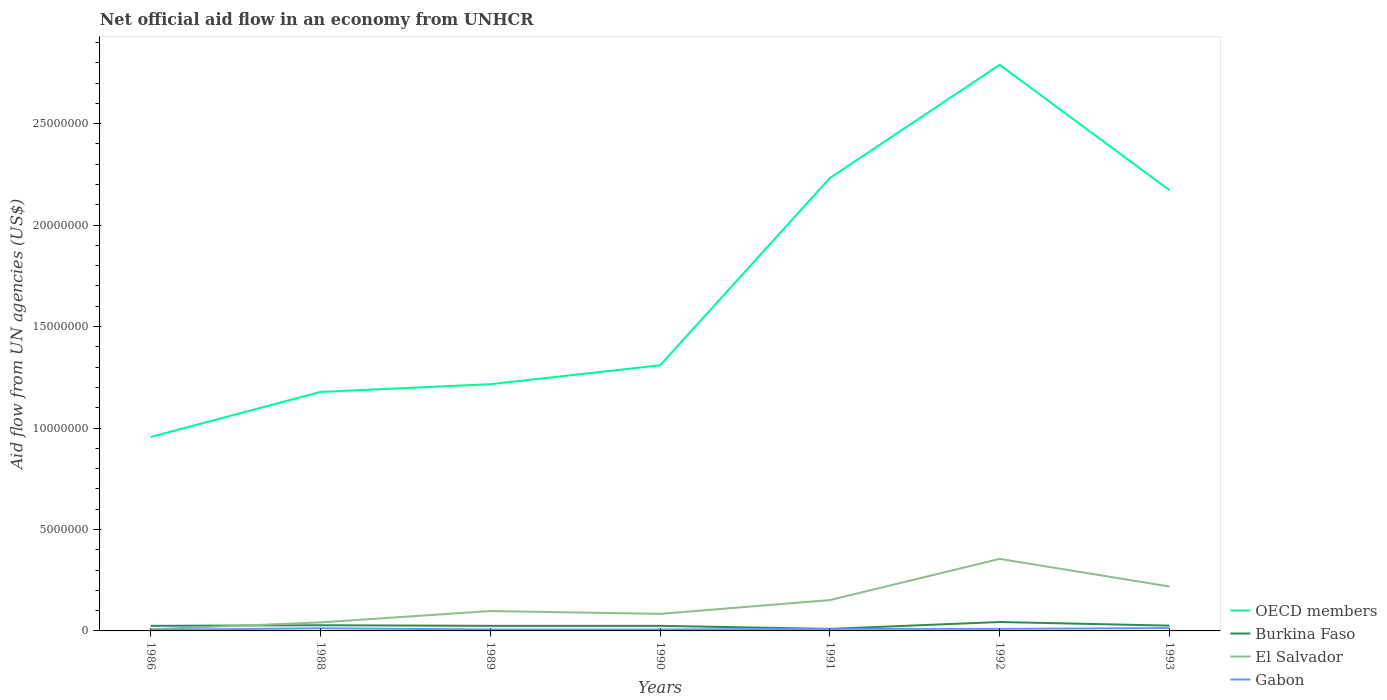Does the line corresponding to Gabon intersect with the line corresponding to El Salvador?
Offer a terse response. No. Is the number of lines equal to the number of legend labels?
Your response must be concise. Yes. Across all years, what is the maximum net official aid flow in Burkina Faso?
Give a very brief answer. 1.00e+05. In which year was the net official aid flow in El Salvador maximum?
Give a very brief answer. 1986. What is the total net official aid flow in OECD members in the graph?
Your answer should be compact. -1.83e+07. What is the difference between the highest and the second highest net official aid flow in OECD members?
Make the answer very short. 1.83e+07. How many years are there in the graph?
Provide a short and direct response. 7. Does the graph contain any zero values?
Offer a terse response. No. Where does the legend appear in the graph?
Offer a very short reply. Bottom right. How many legend labels are there?
Offer a terse response. 4. How are the legend labels stacked?
Give a very brief answer. Vertical. What is the title of the graph?
Provide a succinct answer. Net official aid flow in an economy from UNHCR. What is the label or title of the Y-axis?
Provide a succinct answer. Aid flow from UN agencies (US$). What is the Aid flow from UN agencies (US$) in OECD members in 1986?
Offer a very short reply. 9.56e+06. What is the Aid flow from UN agencies (US$) of El Salvador in 1986?
Your response must be concise. 8.00e+04. What is the Aid flow from UN agencies (US$) in OECD members in 1988?
Offer a terse response. 1.18e+07. What is the Aid flow from UN agencies (US$) of Burkina Faso in 1988?
Ensure brevity in your answer.  2.80e+05. What is the Aid flow from UN agencies (US$) in Gabon in 1988?
Your response must be concise. 1.30e+05. What is the Aid flow from UN agencies (US$) of OECD members in 1989?
Give a very brief answer. 1.22e+07. What is the Aid flow from UN agencies (US$) of El Salvador in 1989?
Offer a very short reply. 9.80e+05. What is the Aid flow from UN agencies (US$) of OECD members in 1990?
Your response must be concise. 1.31e+07. What is the Aid flow from UN agencies (US$) in El Salvador in 1990?
Provide a short and direct response. 8.40e+05. What is the Aid flow from UN agencies (US$) in OECD members in 1991?
Offer a very short reply. 2.23e+07. What is the Aid flow from UN agencies (US$) in El Salvador in 1991?
Give a very brief answer. 1.52e+06. What is the Aid flow from UN agencies (US$) of OECD members in 1992?
Give a very brief answer. 2.79e+07. What is the Aid flow from UN agencies (US$) of Burkina Faso in 1992?
Keep it short and to the point. 4.40e+05. What is the Aid flow from UN agencies (US$) of El Salvador in 1992?
Give a very brief answer. 3.55e+06. What is the Aid flow from UN agencies (US$) in OECD members in 1993?
Offer a terse response. 2.17e+07. What is the Aid flow from UN agencies (US$) of El Salvador in 1993?
Ensure brevity in your answer.  2.19e+06. Across all years, what is the maximum Aid flow from UN agencies (US$) of OECD members?
Your answer should be very brief. 2.79e+07. Across all years, what is the maximum Aid flow from UN agencies (US$) of Burkina Faso?
Your answer should be compact. 4.40e+05. Across all years, what is the maximum Aid flow from UN agencies (US$) of El Salvador?
Make the answer very short. 3.55e+06. Across all years, what is the maximum Aid flow from UN agencies (US$) in Gabon?
Your response must be concise. 1.40e+05. Across all years, what is the minimum Aid flow from UN agencies (US$) of OECD members?
Keep it short and to the point. 9.56e+06. Across all years, what is the minimum Aid flow from UN agencies (US$) in El Salvador?
Your response must be concise. 8.00e+04. Across all years, what is the minimum Aid flow from UN agencies (US$) of Gabon?
Give a very brief answer. 5.00e+04. What is the total Aid flow from UN agencies (US$) in OECD members in the graph?
Your response must be concise. 1.19e+08. What is the total Aid flow from UN agencies (US$) in Burkina Faso in the graph?
Provide a succinct answer. 1.83e+06. What is the total Aid flow from UN agencies (US$) of El Salvador in the graph?
Provide a succinct answer. 9.58e+06. What is the difference between the Aid flow from UN agencies (US$) of OECD members in 1986 and that in 1988?
Give a very brief answer. -2.22e+06. What is the difference between the Aid flow from UN agencies (US$) in El Salvador in 1986 and that in 1988?
Offer a terse response. -3.40e+05. What is the difference between the Aid flow from UN agencies (US$) of Gabon in 1986 and that in 1988?
Give a very brief answer. -8.00e+04. What is the difference between the Aid flow from UN agencies (US$) in OECD members in 1986 and that in 1989?
Give a very brief answer. -2.60e+06. What is the difference between the Aid flow from UN agencies (US$) of Burkina Faso in 1986 and that in 1989?
Your answer should be compact. 0. What is the difference between the Aid flow from UN agencies (US$) of El Salvador in 1986 and that in 1989?
Your answer should be compact. -9.00e+05. What is the difference between the Aid flow from UN agencies (US$) in OECD members in 1986 and that in 1990?
Make the answer very short. -3.53e+06. What is the difference between the Aid flow from UN agencies (US$) in Burkina Faso in 1986 and that in 1990?
Make the answer very short. 0. What is the difference between the Aid flow from UN agencies (US$) of El Salvador in 1986 and that in 1990?
Give a very brief answer. -7.60e+05. What is the difference between the Aid flow from UN agencies (US$) of Gabon in 1986 and that in 1990?
Make the answer very short. -2.00e+04. What is the difference between the Aid flow from UN agencies (US$) of OECD members in 1986 and that in 1991?
Keep it short and to the point. -1.28e+07. What is the difference between the Aid flow from UN agencies (US$) in El Salvador in 1986 and that in 1991?
Keep it short and to the point. -1.44e+06. What is the difference between the Aid flow from UN agencies (US$) in Gabon in 1986 and that in 1991?
Make the answer very short. -5.00e+04. What is the difference between the Aid flow from UN agencies (US$) in OECD members in 1986 and that in 1992?
Your answer should be compact. -1.83e+07. What is the difference between the Aid flow from UN agencies (US$) in El Salvador in 1986 and that in 1992?
Offer a terse response. -3.47e+06. What is the difference between the Aid flow from UN agencies (US$) of OECD members in 1986 and that in 1993?
Provide a short and direct response. -1.22e+07. What is the difference between the Aid flow from UN agencies (US$) of El Salvador in 1986 and that in 1993?
Provide a succinct answer. -2.11e+06. What is the difference between the Aid flow from UN agencies (US$) in Gabon in 1986 and that in 1993?
Offer a terse response. -9.00e+04. What is the difference between the Aid flow from UN agencies (US$) of OECD members in 1988 and that in 1989?
Offer a very short reply. -3.80e+05. What is the difference between the Aid flow from UN agencies (US$) of Burkina Faso in 1988 and that in 1989?
Make the answer very short. 3.00e+04. What is the difference between the Aid flow from UN agencies (US$) of El Salvador in 1988 and that in 1989?
Ensure brevity in your answer.  -5.60e+05. What is the difference between the Aid flow from UN agencies (US$) in Gabon in 1988 and that in 1989?
Provide a short and direct response. 6.00e+04. What is the difference between the Aid flow from UN agencies (US$) in OECD members in 1988 and that in 1990?
Make the answer very short. -1.31e+06. What is the difference between the Aid flow from UN agencies (US$) of Burkina Faso in 1988 and that in 1990?
Ensure brevity in your answer.  3.00e+04. What is the difference between the Aid flow from UN agencies (US$) of El Salvador in 1988 and that in 1990?
Give a very brief answer. -4.20e+05. What is the difference between the Aid flow from UN agencies (US$) in Gabon in 1988 and that in 1990?
Give a very brief answer. 6.00e+04. What is the difference between the Aid flow from UN agencies (US$) in OECD members in 1988 and that in 1991?
Give a very brief answer. -1.05e+07. What is the difference between the Aid flow from UN agencies (US$) in El Salvador in 1988 and that in 1991?
Ensure brevity in your answer.  -1.10e+06. What is the difference between the Aid flow from UN agencies (US$) in OECD members in 1988 and that in 1992?
Keep it short and to the point. -1.61e+07. What is the difference between the Aid flow from UN agencies (US$) in Burkina Faso in 1988 and that in 1992?
Your answer should be very brief. -1.60e+05. What is the difference between the Aid flow from UN agencies (US$) in El Salvador in 1988 and that in 1992?
Offer a terse response. -3.13e+06. What is the difference between the Aid flow from UN agencies (US$) of OECD members in 1988 and that in 1993?
Offer a terse response. -9.94e+06. What is the difference between the Aid flow from UN agencies (US$) of Burkina Faso in 1988 and that in 1993?
Ensure brevity in your answer.  2.00e+04. What is the difference between the Aid flow from UN agencies (US$) of El Salvador in 1988 and that in 1993?
Your answer should be very brief. -1.77e+06. What is the difference between the Aid flow from UN agencies (US$) of Gabon in 1988 and that in 1993?
Offer a terse response. -10000. What is the difference between the Aid flow from UN agencies (US$) of OECD members in 1989 and that in 1990?
Make the answer very short. -9.30e+05. What is the difference between the Aid flow from UN agencies (US$) in Gabon in 1989 and that in 1990?
Make the answer very short. 0. What is the difference between the Aid flow from UN agencies (US$) of OECD members in 1989 and that in 1991?
Your response must be concise. -1.02e+07. What is the difference between the Aid flow from UN agencies (US$) in Burkina Faso in 1989 and that in 1991?
Give a very brief answer. 1.50e+05. What is the difference between the Aid flow from UN agencies (US$) of El Salvador in 1989 and that in 1991?
Provide a succinct answer. -5.40e+05. What is the difference between the Aid flow from UN agencies (US$) in Gabon in 1989 and that in 1991?
Offer a very short reply. -3.00e+04. What is the difference between the Aid flow from UN agencies (US$) in OECD members in 1989 and that in 1992?
Give a very brief answer. -1.57e+07. What is the difference between the Aid flow from UN agencies (US$) of Burkina Faso in 1989 and that in 1992?
Your answer should be compact. -1.90e+05. What is the difference between the Aid flow from UN agencies (US$) of El Salvador in 1989 and that in 1992?
Give a very brief answer. -2.57e+06. What is the difference between the Aid flow from UN agencies (US$) of Gabon in 1989 and that in 1992?
Make the answer very short. -3.00e+04. What is the difference between the Aid flow from UN agencies (US$) of OECD members in 1989 and that in 1993?
Give a very brief answer. -9.56e+06. What is the difference between the Aid flow from UN agencies (US$) in Burkina Faso in 1989 and that in 1993?
Make the answer very short. -10000. What is the difference between the Aid flow from UN agencies (US$) of El Salvador in 1989 and that in 1993?
Make the answer very short. -1.21e+06. What is the difference between the Aid flow from UN agencies (US$) in OECD members in 1990 and that in 1991?
Your answer should be very brief. -9.23e+06. What is the difference between the Aid flow from UN agencies (US$) of El Salvador in 1990 and that in 1991?
Provide a succinct answer. -6.80e+05. What is the difference between the Aid flow from UN agencies (US$) in Gabon in 1990 and that in 1991?
Provide a succinct answer. -3.00e+04. What is the difference between the Aid flow from UN agencies (US$) of OECD members in 1990 and that in 1992?
Provide a short and direct response. -1.48e+07. What is the difference between the Aid flow from UN agencies (US$) in El Salvador in 1990 and that in 1992?
Your response must be concise. -2.71e+06. What is the difference between the Aid flow from UN agencies (US$) of Gabon in 1990 and that in 1992?
Ensure brevity in your answer.  -3.00e+04. What is the difference between the Aid flow from UN agencies (US$) of OECD members in 1990 and that in 1993?
Provide a short and direct response. -8.63e+06. What is the difference between the Aid flow from UN agencies (US$) in El Salvador in 1990 and that in 1993?
Ensure brevity in your answer.  -1.35e+06. What is the difference between the Aid flow from UN agencies (US$) of Gabon in 1990 and that in 1993?
Offer a terse response. -7.00e+04. What is the difference between the Aid flow from UN agencies (US$) of OECD members in 1991 and that in 1992?
Your response must be concise. -5.58e+06. What is the difference between the Aid flow from UN agencies (US$) in El Salvador in 1991 and that in 1992?
Your answer should be compact. -2.03e+06. What is the difference between the Aid flow from UN agencies (US$) of Gabon in 1991 and that in 1992?
Provide a short and direct response. 0. What is the difference between the Aid flow from UN agencies (US$) of OECD members in 1991 and that in 1993?
Offer a terse response. 6.00e+05. What is the difference between the Aid flow from UN agencies (US$) in Burkina Faso in 1991 and that in 1993?
Keep it short and to the point. -1.60e+05. What is the difference between the Aid flow from UN agencies (US$) in El Salvador in 1991 and that in 1993?
Offer a terse response. -6.70e+05. What is the difference between the Aid flow from UN agencies (US$) in Gabon in 1991 and that in 1993?
Provide a succinct answer. -4.00e+04. What is the difference between the Aid flow from UN agencies (US$) of OECD members in 1992 and that in 1993?
Your response must be concise. 6.18e+06. What is the difference between the Aid flow from UN agencies (US$) in El Salvador in 1992 and that in 1993?
Make the answer very short. 1.36e+06. What is the difference between the Aid flow from UN agencies (US$) of Gabon in 1992 and that in 1993?
Provide a succinct answer. -4.00e+04. What is the difference between the Aid flow from UN agencies (US$) of OECD members in 1986 and the Aid flow from UN agencies (US$) of Burkina Faso in 1988?
Your answer should be compact. 9.28e+06. What is the difference between the Aid flow from UN agencies (US$) in OECD members in 1986 and the Aid flow from UN agencies (US$) in El Salvador in 1988?
Provide a succinct answer. 9.14e+06. What is the difference between the Aid flow from UN agencies (US$) in OECD members in 1986 and the Aid flow from UN agencies (US$) in Gabon in 1988?
Offer a terse response. 9.43e+06. What is the difference between the Aid flow from UN agencies (US$) of Burkina Faso in 1986 and the Aid flow from UN agencies (US$) of El Salvador in 1988?
Keep it short and to the point. -1.70e+05. What is the difference between the Aid flow from UN agencies (US$) of El Salvador in 1986 and the Aid flow from UN agencies (US$) of Gabon in 1988?
Your response must be concise. -5.00e+04. What is the difference between the Aid flow from UN agencies (US$) of OECD members in 1986 and the Aid flow from UN agencies (US$) of Burkina Faso in 1989?
Give a very brief answer. 9.31e+06. What is the difference between the Aid flow from UN agencies (US$) of OECD members in 1986 and the Aid flow from UN agencies (US$) of El Salvador in 1989?
Offer a terse response. 8.58e+06. What is the difference between the Aid flow from UN agencies (US$) in OECD members in 1986 and the Aid flow from UN agencies (US$) in Gabon in 1989?
Offer a very short reply. 9.49e+06. What is the difference between the Aid flow from UN agencies (US$) of Burkina Faso in 1986 and the Aid flow from UN agencies (US$) of El Salvador in 1989?
Offer a very short reply. -7.30e+05. What is the difference between the Aid flow from UN agencies (US$) in OECD members in 1986 and the Aid flow from UN agencies (US$) in Burkina Faso in 1990?
Ensure brevity in your answer.  9.31e+06. What is the difference between the Aid flow from UN agencies (US$) in OECD members in 1986 and the Aid flow from UN agencies (US$) in El Salvador in 1990?
Offer a terse response. 8.72e+06. What is the difference between the Aid flow from UN agencies (US$) of OECD members in 1986 and the Aid flow from UN agencies (US$) of Gabon in 1990?
Offer a very short reply. 9.49e+06. What is the difference between the Aid flow from UN agencies (US$) of Burkina Faso in 1986 and the Aid flow from UN agencies (US$) of El Salvador in 1990?
Your answer should be very brief. -5.90e+05. What is the difference between the Aid flow from UN agencies (US$) of Burkina Faso in 1986 and the Aid flow from UN agencies (US$) of Gabon in 1990?
Your response must be concise. 1.80e+05. What is the difference between the Aid flow from UN agencies (US$) of El Salvador in 1986 and the Aid flow from UN agencies (US$) of Gabon in 1990?
Your response must be concise. 10000. What is the difference between the Aid flow from UN agencies (US$) in OECD members in 1986 and the Aid flow from UN agencies (US$) in Burkina Faso in 1991?
Provide a short and direct response. 9.46e+06. What is the difference between the Aid flow from UN agencies (US$) of OECD members in 1986 and the Aid flow from UN agencies (US$) of El Salvador in 1991?
Your answer should be compact. 8.04e+06. What is the difference between the Aid flow from UN agencies (US$) of OECD members in 1986 and the Aid flow from UN agencies (US$) of Gabon in 1991?
Give a very brief answer. 9.46e+06. What is the difference between the Aid flow from UN agencies (US$) in Burkina Faso in 1986 and the Aid flow from UN agencies (US$) in El Salvador in 1991?
Offer a terse response. -1.27e+06. What is the difference between the Aid flow from UN agencies (US$) of Burkina Faso in 1986 and the Aid flow from UN agencies (US$) of Gabon in 1991?
Ensure brevity in your answer.  1.50e+05. What is the difference between the Aid flow from UN agencies (US$) in El Salvador in 1986 and the Aid flow from UN agencies (US$) in Gabon in 1991?
Provide a short and direct response. -2.00e+04. What is the difference between the Aid flow from UN agencies (US$) of OECD members in 1986 and the Aid flow from UN agencies (US$) of Burkina Faso in 1992?
Keep it short and to the point. 9.12e+06. What is the difference between the Aid flow from UN agencies (US$) in OECD members in 1986 and the Aid flow from UN agencies (US$) in El Salvador in 1992?
Offer a terse response. 6.01e+06. What is the difference between the Aid flow from UN agencies (US$) of OECD members in 1986 and the Aid flow from UN agencies (US$) of Gabon in 1992?
Offer a very short reply. 9.46e+06. What is the difference between the Aid flow from UN agencies (US$) in Burkina Faso in 1986 and the Aid flow from UN agencies (US$) in El Salvador in 1992?
Your answer should be very brief. -3.30e+06. What is the difference between the Aid flow from UN agencies (US$) of Burkina Faso in 1986 and the Aid flow from UN agencies (US$) of Gabon in 1992?
Ensure brevity in your answer.  1.50e+05. What is the difference between the Aid flow from UN agencies (US$) of El Salvador in 1986 and the Aid flow from UN agencies (US$) of Gabon in 1992?
Provide a short and direct response. -2.00e+04. What is the difference between the Aid flow from UN agencies (US$) in OECD members in 1986 and the Aid flow from UN agencies (US$) in Burkina Faso in 1993?
Your response must be concise. 9.30e+06. What is the difference between the Aid flow from UN agencies (US$) in OECD members in 1986 and the Aid flow from UN agencies (US$) in El Salvador in 1993?
Offer a terse response. 7.37e+06. What is the difference between the Aid flow from UN agencies (US$) in OECD members in 1986 and the Aid flow from UN agencies (US$) in Gabon in 1993?
Your answer should be very brief. 9.42e+06. What is the difference between the Aid flow from UN agencies (US$) of Burkina Faso in 1986 and the Aid flow from UN agencies (US$) of El Salvador in 1993?
Ensure brevity in your answer.  -1.94e+06. What is the difference between the Aid flow from UN agencies (US$) in Burkina Faso in 1986 and the Aid flow from UN agencies (US$) in Gabon in 1993?
Your answer should be compact. 1.10e+05. What is the difference between the Aid flow from UN agencies (US$) in El Salvador in 1986 and the Aid flow from UN agencies (US$) in Gabon in 1993?
Ensure brevity in your answer.  -6.00e+04. What is the difference between the Aid flow from UN agencies (US$) of OECD members in 1988 and the Aid flow from UN agencies (US$) of Burkina Faso in 1989?
Provide a succinct answer. 1.15e+07. What is the difference between the Aid flow from UN agencies (US$) of OECD members in 1988 and the Aid flow from UN agencies (US$) of El Salvador in 1989?
Offer a terse response. 1.08e+07. What is the difference between the Aid flow from UN agencies (US$) in OECD members in 1988 and the Aid flow from UN agencies (US$) in Gabon in 1989?
Keep it short and to the point. 1.17e+07. What is the difference between the Aid flow from UN agencies (US$) of Burkina Faso in 1988 and the Aid flow from UN agencies (US$) of El Salvador in 1989?
Offer a very short reply. -7.00e+05. What is the difference between the Aid flow from UN agencies (US$) in Burkina Faso in 1988 and the Aid flow from UN agencies (US$) in Gabon in 1989?
Ensure brevity in your answer.  2.10e+05. What is the difference between the Aid flow from UN agencies (US$) in El Salvador in 1988 and the Aid flow from UN agencies (US$) in Gabon in 1989?
Your response must be concise. 3.50e+05. What is the difference between the Aid flow from UN agencies (US$) in OECD members in 1988 and the Aid flow from UN agencies (US$) in Burkina Faso in 1990?
Your response must be concise. 1.15e+07. What is the difference between the Aid flow from UN agencies (US$) of OECD members in 1988 and the Aid flow from UN agencies (US$) of El Salvador in 1990?
Your answer should be very brief. 1.09e+07. What is the difference between the Aid flow from UN agencies (US$) of OECD members in 1988 and the Aid flow from UN agencies (US$) of Gabon in 1990?
Give a very brief answer. 1.17e+07. What is the difference between the Aid flow from UN agencies (US$) of Burkina Faso in 1988 and the Aid flow from UN agencies (US$) of El Salvador in 1990?
Your response must be concise. -5.60e+05. What is the difference between the Aid flow from UN agencies (US$) of OECD members in 1988 and the Aid flow from UN agencies (US$) of Burkina Faso in 1991?
Keep it short and to the point. 1.17e+07. What is the difference between the Aid flow from UN agencies (US$) in OECD members in 1988 and the Aid flow from UN agencies (US$) in El Salvador in 1991?
Your answer should be compact. 1.03e+07. What is the difference between the Aid flow from UN agencies (US$) of OECD members in 1988 and the Aid flow from UN agencies (US$) of Gabon in 1991?
Your response must be concise. 1.17e+07. What is the difference between the Aid flow from UN agencies (US$) in Burkina Faso in 1988 and the Aid flow from UN agencies (US$) in El Salvador in 1991?
Give a very brief answer. -1.24e+06. What is the difference between the Aid flow from UN agencies (US$) of El Salvador in 1988 and the Aid flow from UN agencies (US$) of Gabon in 1991?
Offer a very short reply. 3.20e+05. What is the difference between the Aid flow from UN agencies (US$) in OECD members in 1988 and the Aid flow from UN agencies (US$) in Burkina Faso in 1992?
Offer a terse response. 1.13e+07. What is the difference between the Aid flow from UN agencies (US$) in OECD members in 1988 and the Aid flow from UN agencies (US$) in El Salvador in 1992?
Give a very brief answer. 8.23e+06. What is the difference between the Aid flow from UN agencies (US$) of OECD members in 1988 and the Aid flow from UN agencies (US$) of Gabon in 1992?
Provide a short and direct response. 1.17e+07. What is the difference between the Aid flow from UN agencies (US$) of Burkina Faso in 1988 and the Aid flow from UN agencies (US$) of El Salvador in 1992?
Make the answer very short. -3.27e+06. What is the difference between the Aid flow from UN agencies (US$) in Burkina Faso in 1988 and the Aid flow from UN agencies (US$) in Gabon in 1992?
Your answer should be compact. 1.80e+05. What is the difference between the Aid flow from UN agencies (US$) in El Salvador in 1988 and the Aid flow from UN agencies (US$) in Gabon in 1992?
Offer a very short reply. 3.20e+05. What is the difference between the Aid flow from UN agencies (US$) in OECD members in 1988 and the Aid flow from UN agencies (US$) in Burkina Faso in 1993?
Your answer should be very brief. 1.15e+07. What is the difference between the Aid flow from UN agencies (US$) of OECD members in 1988 and the Aid flow from UN agencies (US$) of El Salvador in 1993?
Your answer should be very brief. 9.59e+06. What is the difference between the Aid flow from UN agencies (US$) in OECD members in 1988 and the Aid flow from UN agencies (US$) in Gabon in 1993?
Your answer should be compact. 1.16e+07. What is the difference between the Aid flow from UN agencies (US$) in Burkina Faso in 1988 and the Aid flow from UN agencies (US$) in El Salvador in 1993?
Your response must be concise. -1.91e+06. What is the difference between the Aid flow from UN agencies (US$) in Burkina Faso in 1988 and the Aid flow from UN agencies (US$) in Gabon in 1993?
Provide a short and direct response. 1.40e+05. What is the difference between the Aid flow from UN agencies (US$) in OECD members in 1989 and the Aid flow from UN agencies (US$) in Burkina Faso in 1990?
Your answer should be compact. 1.19e+07. What is the difference between the Aid flow from UN agencies (US$) in OECD members in 1989 and the Aid flow from UN agencies (US$) in El Salvador in 1990?
Give a very brief answer. 1.13e+07. What is the difference between the Aid flow from UN agencies (US$) of OECD members in 1989 and the Aid flow from UN agencies (US$) of Gabon in 1990?
Make the answer very short. 1.21e+07. What is the difference between the Aid flow from UN agencies (US$) of Burkina Faso in 1989 and the Aid flow from UN agencies (US$) of El Salvador in 1990?
Provide a succinct answer. -5.90e+05. What is the difference between the Aid flow from UN agencies (US$) in El Salvador in 1989 and the Aid flow from UN agencies (US$) in Gabon in 1990?
Your answer should be compact. 9.10e+05. What is the difference between the Aid flow from UN agencies (US$) of OECD members in 1989 and the Aid flow from UN agencies (US$) of Burkina Faso in 1991?
Make the answer very short. 1.21e+07. What is the difference between the Aid flow from UN agencies (US$) of OECD members in 1989 and the Aid flow from UN agencies (US$) of El Salvador in 1991?
Offer a very short reply. 1.06e+07. What is the difference between the Aid flow from UN agencies (US$) in OECD members in 1989 and the Aid flow from UN agencies (US$) in Gabon in 1991?
Provide a short and direct response. 1.21e+07. What is the difference between the Aid flow from UN agencies (US$) in Burkina Faso in 1989 and the Aid flow from UN agencies (US$) in El Salvador in 1991?
Your response must be concise. -1.27e+06. What is the difference between the Aid flow from UN agencies (US$) in El Salvador in 1989 and the Aid flow from UN agencies (US$) in Gabon in 1991?
Your response must be concise. 8.80e+05. What is the difference between the Aid flow from UN agencies (US$) of OECD members in 1989 and the Aid flow from UN agencies (US$) of Burkina Faso in 1992?
Keep it short and to the point. 1.17e+07. What is the difference between the Aid flow from UN agencies (US$) in OECD members in 1989 and the Aid flow from UN agencies (US$) in El Salvador in 1992?
Your response must be concise. 8.61e+06. What is the difference between the Aid flow from UN agencies (US$) in OECD members in 1989 and the Aid flow from UN agencies (US$) in Gabon in 1992?
Keep it short and to the point. 1.21e+07. What is the difference between the Aid flow from UN agencies (US$) in Burkina Faso in 1989 and the Aid flow from UN agencies (US$) in El Salvador in 1992?
Your answer should be very brief. -3.30e+06. What is the difference between the Aid flow from UN agencies (US$) in Burkina Faso in 1989 and the Aid flow from UN agencies (US$) in Gabon in 1992?
Ensure brevity in your answer.  1.50e+05. What is the difference between the Aid flow from UN agencies (US$) of El Salvador in 1989 and the Aid flow from UN agencies (US$) of Gabon in 1992?
Offer a very short reply. 8.80e+05. What is the difference between the Aid flow from UN agencies (US$) of OECD members in 1989 and the Aid flow from UN agencies (US$) of Burkina Faso in 1993?
Your response must be concise. 1.19e+07. What is the difference between the Aid flow from UN agencies (US$) in OECD members in 1989 and the Aid flow from UN agencies (US$) in El Salvador in 1993?
Offer a terse response. 9.97e+06. What is the difference between the Aid flow from UN agencies (US$) in OECD members in 1989 and the Aid flow from UN agencies (US$) in Gabon in 1993?
Make the answer very short. 1.20e+07. What is the difference between the Aid flow from UN agencies (US$) of Burkina Faso in 1989 and the Aid flow from UN agencies (US$) of El Salvador in 1993?
Ensure brevity in your answer.  -1.94e+06. What is the difference between the Aid flow from UN agencies (US$) in Burkina Faso in 1989 and the Aid flow from UN agencies (US$) in Gabon in 1993?
Ensure brevity in your answer.  1.10e+05. What is the difference between the Aid flow from UN agencies (US$) of El Salvador in 1989 and the Aid flow from UN agencies (US$) of Gabon in 1993?
Your answer should be compact. 8.40e+05. What is the difference between the Aid flow from UN agencies (US$) in OECD members in 1990 and the Aid flow from UN agencies (US$) in Burkina Faso in 1991?
Make the answer very short. 1.30e+07. What is the difference between the Aid flow from UN agencies (US$) in OECD members in 1990 and the Aid flow from UN agencies (US$) in El Salvador in 1991?
Your response must be concise. 1.16e+07. What is the difference between the Aid flow from UN agencies (US$) of OECD members in 1990 and the Aid flow from UN agencies (US$) of Gabon in 1991?
Make the answer very short. 1.30e+07. What is the difference between the Aid flow from UN agencies (US$) in Burkina Faso in 1990 and the Aid flow from UN agencies (US$) in El Salvador in 1991?
Your answer should be compact. -1.27e+06. What is the difference between the Aid flow from UN agencies (US$) of Burkina Faso in 1990 and the Aid flow from UN agencies (US$) of Gabon in 1991?
Your response must be concise. 1.50e+05. What is the difference between the Aid flow from UN agencies (US$) of El Salvador in 1990 and the Aid flow from UN agencies (US$) of Gabon in 1991?
Give a very brief answer. 7.40e+05. What is the difference between the Aid flow from UN agencies (US$) in OECD members in 1990 and the Aid flow from UN agencies (US$) in Burkina Faso in 1992?
Your answer should be very brief. 1.26e+07. What is the difference between the Aid flow from UN agencies (US$) in OECD members in 1990 and the Aid flow from UN agencies (US$) in El Salvador in 1992?
Keep it short and to the point. 9.54e+06. What is the difference between the Aid flow from UN agencies (US$) in OECD members in 1990 and the Aid flow from UN agencies (US$) in Gabon in 1992?
Your response must be concise. 1.30e+07. What is the difference between the Aid flow from UN agencies (US$) in Burkina Faso in 1990 and the Aid flow from UN agencies (US$) in El Salvador in 1992?
Keep it short and to the point. -3.30e+06. What is the difference between the Aid flow from UN agencies (US$) in El Salvador in 1990 and the Aid flow from UN agencies (US$) in Gabon in 1992?
Ensure brevity in your answer.  7.40e+05. What is the difference between the Aid flow from UN agencies (US$) of OECD members in 1990 and the Aid flow from UN agencies (US$) of Burkina Faso in 1993?
Provide a short and direct response. 1.28e+07. What is the difference between the Aid flow from UN agencies (US$) in OECD members in 1990 and the Aid flow from UN agencies (US$) in El Salvador in 1993?
Ensure brevity in your answer.  1.09e+07. What is the difference between the Aid flow from UN agencies (US$) in OECD members in 1990 and the Aid flow from UN agencies (US$) in Gabon in 1993?
Make the answer very short. 1.30e+07. What is the difference between the Aid flow from UN agencies (US$) of Burkina Faso in 1990 and the Aid flow from UN agencies (US$) of El Salvador in 1993?
Your answer should be compact. -1.94e+06. What is the difference between the Aid flow from UN agencies (US$) in OECD members in 1991 and the Aid flow from UN agencies (US$) in Burkina Faso in 1992?
Ensure brevity in your answer.  2.19e+07. What is the difference between the Aid flow from UN agencies (US$) of OECD members in 1991 and the Aid flow from UN agencies (US$) of El Salvador in 1992?
Offer a very short reply. 1.88e+07. What is the difference between the Aid flow from UN agencies (US$) in OECD members in 1991 and the Aid flow from UN agencies (US$) in Gabon in 1992?
Your response must be concise. 2.22e+07. What is the difference between the Aid flow from UN agencies (US$) in Burkina Faso in 1991 and the Aid flow from UN agencies (US$) in El Salvador in 1992?
Your answer should be compact. -3.45e+06. What is the difference between the Aid flow from UN agencies (US$) of Burkina Faso in 1991 and the Aid flow from UN agencies (US$) of Gabon in 1992?
Provide a short and direct response. 0. What is the difference between the Aid flow from UN agencies (US$) of El Salvador in 1991 and the Aid flow from UN agencies (US$) of Gabon in 1992?
Ensure brevity in your answer.  1.42e+06. What is the difference between the Aid flow from UN agencies (US$) in OECD members in 1991 and the Aid flow from UN agencies (US$) in Burkina Faso in 1993?
Offer a terse response. 2.21e+07. What is the difference between the Aid flow from UN agencies (US$) of OECD members in 1991 and the Aid flow from UN agencies (US$) of El Salvador in 1993?
Your response must be concise. 2.01e+07. What is the difference between the Aid flow from UN agencies (US$) in OECD members in 1991 and the Aid flow from UN agencies (US$) in Gabon in 1993?
Your answer should be very brief. 2.22e+07. What is the difference between the Aid flow from UN agencies (US$) of Burkina Faso in 1991 and the Aid flow from UN agencies (US$) of El Salvador in 1993?
Give a very brief answer. -2.09e+06. What is the difference between the Aid flow from UN agencies (US$) in Burkina Faso in 1991 and the Aid flow from UN agencies (US$) in Gabon in 1993?
Give a very brief answer. -4.00e+04. What is the difference between the Aid flow from UN agencies (US$) of El Salvador in 1991 and the Aid flow from UN agencies (US$) of Gabon in 1993?
Provide a succinct answer. 1.38e+06. What is the difference between the Aid flow from UN agencies (US$) in OECD members in 1992 and the Aid flow from UN agencies (US$) in Burkina Faso in 1993?
Offer a very short reply. 2.76e+07. What is the difference between the Aid flow from UN agencies (US$) in OECD members in 1992 and the Aid flow from UN agencies (US$) in El Salvador in 1993?
Offer a very short reply. 2.57e+07. What is the difference between the Aid flow from UN agencies (US$) in OECD members in 1992 and the Aid flow from UN agencies (US$) in Gabon in 1993?
Your answer should be compact. 2.78e+07. What is the difference between the Aid flow from UN agencies (US$) in Burkina Faso in 1992 and the Aid flow from UN agencies (US$) in El Salvador in 1993?
Provide a short and direct response. -1.75e+06. What is the difference between the Aid flow from UN agencies (US$) of Burkina Faso in 1992 and the Aid flow from UN agencies (US$) of Gabon in 1993?
Your response must be concise. 3.00e+05. What is the difference between the Aid flow from UN agencies (US$) of El Salvador in 1992 and the Aid flow from UN agencies (US$) of Gabon in 1993?
Make the answer very short. 3.41e+06. What is the average Aid flow from UN agencies (US$) in OECD members per year?
Your answer should be very brief. 1.69e+07. What is the average Aid flow from UN agencies (US$) of Burkina Faso per year?
Provide a succinct answer. 2.61e+05. What is the average Aid flow from UN agencies (US$) of El Salvador per year?
Your answer should be very brief. 1.37e+06. What is the average Aid flow from UN agencies (US$) in Gabon per year?
Make the answer very short. 9.43e+04. In the year 1986, what is the difference between the Aid flow from UN agencies (US$) in OECD members and Aid flow from UN agencies (US$) in Burkina Faso?
Your answer should be very brief. 9.31e+06. In the year 1986, what is the difference between the Aid flow from UN agencies (US$) of OECD members and Aid flow from UN agencies (US$) of El Salvador?
Provide a short and direct response. 9.48e+06. In the year 1986, what is the difference between the Aid flow from UN agencies (US$) in OECD members and Aid flow from UN agencies (US$) in Gabon?
Ensure brevity in your answer.  9.51e+06. In the year 1986, what is the difference between the Aid flow from UN agencies (US$) of Burkina Faso and Aid flow from UN agencies (US$) of El Salvador?
Make the answer very short. 1.70e+05. In the year 1986, what is the difference between the Aid flow from UN agencies (US$) of El Salvador and Aid flow from UN agencies (US$) of Gabon?
Keep it short and to the point. 3.00e+04. In the year 1988, what is the difference between the Aid flow from UN agencies (US$) in OECD members and Aid flow from UN agencies (US$) in Burkina Faso?
Keep it short and to the point. 1.15e+07. In the year 1988, what is the difference between the Aid flow from UN agencies (US$) in OECD members and Aid flow from UN agencies (US$) in El Salvador?
Your response must be concise. 1.14e+07. In the year 1988, what is the difference between the Aid flow from UN agencies (US$) of OECD members and Aid flow from UN agencies (US$) of Gabon?
Offer a very short reply. 1.16e+07. In the year 1989, what is the difference between the Aid flow from UN agencies (US$) in OECD members and Aid flow from UN agencies (US$) in Burkina Faso?
Your answer should be compact. 1.19e+07. In the year 1989, what is the difference between the Aid flow from UN agencies (US$) of OECD members and Aid flow from UN agencies (US$) of El Salvador?
Provide a short and direct response. 1.12e+07. In the year 1989, what is the difference between the Aid flow from UN agencies (US$) in OECD members and Aid flow from UN agencies (US$) in Gabon?
Make the answer very short. 1.21e+07. In the year 1989, what is the difference between the Aid flow from UN agencies (US$) of Burkina Faso and Aid flow from UN agencies (US$) of El Salvador?
Make the answer very short. -7.30e+05. In the year 1989, what is the difference between the Aid flow from UN agencies (US$) of Burkina Faso and Aid flow from UN agencies (US$) of Gabon?
Your answer should be compact. 1.80e+05. In the year 1989, what is the difference between the Aid flow from UN agencies (US$) of El Salvador and Aid flow from UN agencies (US$) of Gabon?
Keep it short and to the point. 9.10e+05. In the year 1990, what is the difference between the Aid flow from UN agencies (US$) in OECD members and Aid flow from UN agencies (US$) in Burkina Faso?
Offer a terse response. 1.28e+07. In the year 1990, what is the difference between the Aid flow from UN agencies (US$) in OECD members and Aid flow from UN agencies (US$) in El Salvador?
Your answer should be very brief. 1.22e+07. In the year 1990, what is the difference between the Aid flow from UN agencies (US$) of OECD members and Aid flow from UN agencies (US$) of Gabon?
Keep it short and to the point. 1.30e+07. In the year 1990, what is the difference between the Aid flow from UN agencies (US$) of Burkina Faso and Aid flow from UN agencies (US$) of El Salvador?
Offer a terse response. -5.90e+05. In the year 1990, what is the difference between the Aid flow from UN agencies (US$) in El Salvador and Aid flow from UN agencies (US$) in Gabon?
Give a very brief answer. 7.70e+05. In the year 1991, what is the difference between the Aid flow from UN agencies (US$) of OECD members and Aid flow from UN agencies (US$) of Burkina Faso?
Provide a succinct answer. 2.22e+07. In the year 1991, what is the difference between the Aid flow from UN agencies (US$) in OECD members and Aid flow from UN agencies (US$) in El Salvador?
Your answer should be very brief. 2.08e+07. In the year 1991, what is the difference between the Aid flow from UN agencies (US$) in OECD members and Aid flow from UN agencies (US$) in Gabon?
Provide a succinct answer. 2.22e+07. In the year 1991, what is the difference between the Aid flow from UN agencies (US$) in Burkina Faso and Aid flow from UN agencies (US$) in El Salvador?
Provide a succinct answer. -1.42e+06. In the year 1991, what is the difference between the Aid flow from UN agencies (US$) of El Salvador and Aid flow from UN agencies (US$) of Gabon?
Your answer should be compact. 1.42e+06. In the year 1992, what is the difference between the Aid flow from UN agencies (US$) of OECD members and Aid flow from UN agencies (US$) of Burkina Faso?
Make the answer very short. 2.75e+07. In the year 1992, what is the difference between the Aid flow from UN agencies (US$) in OECD members and Aid flow from UN agencies (US$) in El Salvador?
Provide a short and direct response. 2.44e+07. In the year 1992, what is the difference between the Aid flow from UN agencies (US$) in OECD members and Aid flow from UN agencies (US$) in Gabon?
Offer a terse response. 2.78e+07. In the year 1992, what is the difference between the Aid flow from UN agencies (US$) in Burkina Faso and Aid flow from UN agencies (US$) in El Salvador?
Offer a terse response. -3.11e+06. In the year 1992, what is the difference between the Aid flow from UN agencies (US$) in Burkina Faso and Aid flow from UN agencies (US$) in Gabon?
Your answer should be very brief. 3.40e+05. In the year 1992, what is the difference between the Aid flow from UN agencies (US$) of El Salvador and Aid flow from UN agencies (US$) of Gabon?
Give a very brief answer. 3.45e+06. In the year 1993, what is the difference between the Aid flow from UN agencies (US$) of OECD members and Aid flow from UN agencies (US$) of Burkina Faso?
Ensure brevity in your answer.  2.15e+07. In the year 1993, what is the difference between the Aid flow from UN agencies (US$) of OECD members and Aid flow from UN agencies (US$) of El Salvador?
Offer a very short reply. 1.95e+07. In the year 1993, what is the difference between the Aid flow from UN agencies (US$) of OECD members and Aid flow from UN agencies (US$) of Gabon?
Your answer should be very brief. 2.16e+07. In the year 1993, what is the difference between the Aid flow from UN agencies (US$) of Burkina Faso and Aid flow from UN agencies (US$) of El Salvador?
Provide a succinct answer. -1.93e+06. In the year 1993, what is the difference between the Aid flow from UN agencies (US$) of El Salvador and Aid flow from UN agencies (US$) of Gabon?
Your response must be concise. 2.05e+06. What is the ratio of the Aid flow from UN agencies (US$) in OECD members in 1986 to that in 1988?
Keep it short and to the point. 0.81. What is the ratio of the Aid flow from UN agencies (US$) of Burkina Faso in 1986 to that in 1988?
Offer a very short reply. 0.89. What is the ratio of the Aid flow from UN agencies (US$) in El Salvador in 1986 to that in 1988?
Offer a very short reply. 0.19. What is the ratio of the Aid flow from UN agencies (US$) in Gabon in 1986 to that in 1988?
Keep it short and to the point. 0.38. What is the ratio of the Aid flow from UN agencies (US$) in OECD members in 1986 to that in 1989?
Keep it short and to the point. 0.79. What is the ratio of the Aid flow from UN agencies (US$) in Burkina Faso in 1986 to that in 1989?
Your response must be concise. 1. What is the ratio of the Aid flow from UN agencies (US$) of El Salvador in 1986 to that in 1989?
Give a very brief answer. 0.08. What is the ratio of the Aid flow from UN agencies (US$) of OECD members in 1986 to that in 1990?
Ensure brevity in your answer.  0.73. What is the ratio of the Aid flow from UN agencies (US$) of El Salvador in 1986 to that in 1990?
Your answer should be compact. 0.1. What is the ratio of the Aid flow from UN agencies (US$) in OECD members in 1986 to that in 1991?
Your answer should be very brief. 0.43. What is the ratio of the Aid flow from UN agencies (US$) of Burkina Faso in 1986 to that in 1991?
Ensure brevity in your answer.  2.5. What is the ratio of the Aid flow from UN agencies (US$) in El Salvador in 1986 to that in 1991?
Your answer should be very brief. 0.05. What is the ratio of the Aid flow from UN agencies (US$) of Gabon in 1986 to that in 1991?
Offer a very short reply. 0.5. What is the ratio of the Aid flow from UN agencies (US$) of OECD members in 1986 to that in 1992?
Make the answer very short. 0.34. What is the ratio of the Aid flow from UN agencies (US$) in Burkina Faso in 1986 to that in 1992?
Offer a very short reply. 0.57. What is the ratio of the Aid flow from UN agencies (US$) of El Salvador in 1986 to that in 1992?
Keep it short and to the point. 0.02. What is the ratio of the Aid flow from UN agencies (US$) in Gabon in 1986 to that in 1992?
Provide a succinct answer. 0.5. What is the ratio of the Aid flow from UN agencies (US$) of OECD members in 1986 to that in 1993?
Offer a terse response. 0.44. What is the ratio of the Aid flow from UN agencies (US$) of Burkina Faso in 1986 to that in 1993?
Offer a terse response. 0.96. What is the ratio of the Aid flow from UN agencies (US$) in El Salvador in 1986 to that in 1993?
Your response must be concise. 0.04. What is the ratio of the Aid flow from UN agencies (US$) of Gabon in 1986 to that in 1993?
Offer a very short reply. 0.36. What is the ratio of the Aid flow from UN agencies (US$) in OECD members in 1988 to that in 1989?
Offer a very short reply. 0.97. What is the ratio of the Aid flow from UN agencies (US$) in Burkina Faso in 1988 to that in 1989?
Offer a terse response. 1.12. What is the ratio of the Aid flow from UN agencies (US$) in El Salvador in 1988 to that in 1989?
Provide a short and direct response. 0.43. What is the ratio of the Aid flow from UN agencies (US$) in Gabon in 1988 to that in 1989?
Give a very brief answer. 1.86. What is the ratio of the Aid flow from UN agencies (US$) of OECD members in 1988 to that in 1990?
Make the answer very short. 0.9. What is the ratio of the Aid flow from UN agencies (US$) in Burkina Faso in 1988 to that in 1990?
Offer a terse response. 1.12. What is the ratio of the Aid flow from UN agencies (US$) of Gabon in 1988 to that in 1990?
Offer a very short reply. 1.86. What is the ratio of the Aid flow from UN agencies (US$) of OECD members in 1988 to that in 1991?
Your answer should be compact. 0.53. What is the ratio of the Aid flow from UN agencies (US$) of El Salvador in 1988 to that in 1991?
Make the answer very short. 0.28. What is the ratio of the Aid flow from UN agencies (US$) of OECD members in 1988 to that in 1992?
Make the answer very short. 0.42. What is the ratio of the Aid flow from UN agencies (US$) in Burkina Faso in 1988 to that in 1992?
Offer a terse response. 0.64. What is the ratio of the Aid flow from UN agencies (US$) in El Salvador in 1988 to that in 1992?
Make the answer very short. 0.12. What is the ratio of the Aid flow from UN agencies (US$) in OECD members in 1988 to that in 1993?
Provide a short and direct response. 0.54. What is the ratio of the Aid flow from UN agencies (US$) of Burkina Faso in 1988 to that in 1993?
Offer a terse response. 1.08. What is the ratio of the Aid flow from UN agencies (US$) in El Salvador in 1988 to that in 1993?
Ensure brevity in your answer.  0.19. What is the ratio of the Aid flow from UN agencies (US$) of Gabon in 1988 to that in 1993?
Your answer should be compact. 0.93. What is the ratio of the Aid flow from UN agencies (US$) in OECD members in 1989 to that in 1990?
Give a very brief answer. 0.93. What is the ratio of the Aid flow from UN agencies (US$) of El Salvador in 1989 to that in 1990?
Your answer should be compact. 1.17. What is the ratio of the Aid flow from UN agencies (US$) of Gabon in 1989 to that in 1990?
Your answer should be very brief. 1. What is the ratio of the Aid flow from UN agencies (US$) in OECD members in 1989 to that in 1991?
Ensure brevity in your answer.  0.54. What is the ratio of the Aid flow from UN agencies (US$) in Burkina Faso in 1989 to that in 1991?
Give a very brief answer. 2.5. What is the ratio of the Aid flow from UN agencies (US$) in El Salvador in 1989 to that in 1991?
Provide a short and direct response. 0.64. What is the ratio of the Aid flow from UN agencies (US$) in Gabon in 1989 to that in 1991?
Keep it short and to the point. 0.7. What is the ratio of the Aid flow from UN agencies (US$) in OECD members in 1989 to that in 1992?
Give a very brief answer. 0.44. What is the ratio of the Aid flow from UN agencies (US$) in Burkina Faso in 1989 to that in 1992?
Offer a very short reply. 0.57. What is the ratio of the Aid flow from UN agencies (US$) in El Salvador in 1989 to that in 1992?
Keep it short and to the point. 0.28. What is the ratio of the Aid flow from UN agencies (US$) of OECD members in 1989 to that in 1993?
Your answer should be very brief. 0.56. What is the ratio of the Aid flow from UN agencies (US$) of Burkina Faso in 1989 to that in 1993?
Offer a terse response. 0.96. What is the ratio of the Aid flow from UN agencies (US$) in El Salvador in 1989 to that in 1993?
Your response must be concise. 0.45. What is the ratio of the Aid flow from UN agencies (US$) in Gabon in 1989 to that in 1993?
Your answer should be very brief. 0.5. What is the ratio of the Aid flow from UN agencies (US$) in OECD members in 1990 to that in 1991?
Your answer should be very brief. 0.59. What is the ratio of the Aid flow from UN agencies (US$) of Burkina Faso in 1990 to that in 1991?
Offer a terse response. 2.5. What is the ratio of the Aid flow from UN agencies (US$) in El Salvador in 1990 to that in 1991?
Offer a terse response. 0.55. What is the ratio of the Aid flow from UN agencies (US$) in Gabon in 1990 to that in 1991?
Your response must be concise. 0.7. What is the ratio of the Aid flow from UN agencies (US$) of OECD members in 1990 to that in 1992?
Keep it short and to the point. 0.47. What is the ratio of the Aid flow from UN agencies (US$) in Burkina Faso in 1990 to that in 1992?
Give a very brief answer. 0.57. What is the ratio of the Aid flow from UN agencies (US$) in El Salvador in 1990 to that in 1992?
Offer a very short reply. 0.24. What is the ratio of the Aid flow from UN agencies (US$) of OECD members in 1990 to that in 1993?
Offer a very short reply. 0.6. What is the ratio of the Aid flow from UN agencies (US$) in Burkina Faso in 1990 to that in 1993?
Your answer should be very brief. 0.96. What is the ratio of the Aid flow from UN agencies (US$) in El Salvador in 1990 to that in 1993?
Your response must be concise. 0.38. What is the ratio of the Aid flow from UN agencies (US$) in Gabon in 1990 to that in 1993?
Offer a very short reply. 0.5. What is the ratio of the Aid flow from UN agencies (US$) of OECD members in 1991 to that in 1992?
Your response must be concise. 0.8. What is the ratio of the Aid flow from UN agencies (US$) of Burkina Faso in 1991 to that in 1992?
Ensure brevity in your answer.  0.23. What is the ratio of the Aid flow from UN agencies (US$) of El Salvador in 1991 to that in 1992?
Your answer should be very brief. 0.43. What is the ratio of the Aid flow from UN agencies (US$) of Gabon in 1991 to that in 1992?
Your response must be concise. 1. What is the ratio of the Aid flow from UN agencies (US$) of OECD members in 1991 to that in 1993?
Offer a very short reply. 1.03. What is the ratio of the Aid flow from UN agencies (US$) of Burkina Faso in 1991 to that in 1993?
Keep it short and to the point. 0.38. What is the ratio of the Aid flow from UN agencies (US$) in El Salvador in 1991 to that in 1993?
Keep it short and to the point. 0.69. What is the ratio of the Aid flow from UN agencies (US$) in Gabon in 1991 to that in 1993?
Your answer should be very brief. 0.71. What is the ratio of the Aid flow from UN agencies (US$) in OECD members in 1992 to that in 1993?
Provide a short and direct response. 1.28. What is the ratio of the Aid flow from UN agencies (US$) of Burkina Faso in 1992 to that in 1993?
Provide a short and direct response. 1.69. What is the ratio of the Aid flow from UN agencies (US$) of El Salvador in 1992 to that in 1993?
Offer a very short reply. 1.62. What is the difference between the highest and the second highest Aid flow from UN agencies (US$) in OECD members?
Offer a very short reply. 5.58e+06. What is the difference between the highest and the second highest Aid flow from UN agencies (US$) of Burkina Faso?
Offer a terse response. 1.60e+05. What is the difference between the highest and the second highest Aid flow from UN agencies (US$) in El Salvador?
Make the answer very short. 1.36e+06. What is the difference between the highest and the second highest Aid flow from UN agencies (US$) of Gabon?
Give a very brief answer. 10000. What is the difference between the highest and the lowest Aid flow from UN agencies (US$) in OECD members?
Provide a short and direct response. 1.83e+07. What is the difference between the highest and the lowest Aid flow from UN agencies (US$) of El Salvador?
Provide a short and direct response. 3.47e+06. 